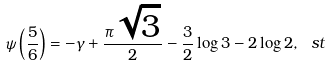Convert formula to latex. <formula><loc_0><loc_0><loc_500><loc_500>\psi \left ( \frac { 5 } { 6 } \right ) = - \gamma + \frac { \pi \sqrt { 3 } } { 2 } - \frac { 3 } { 2 } \log 3 - 2 \log 2 , \ s t</formula> 